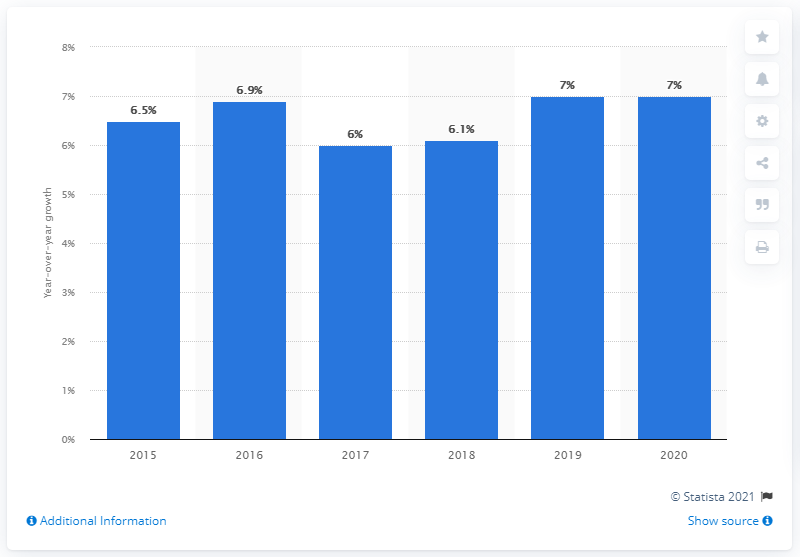Mention a couple of crucial points in this snapshot. Global business travel spending is expected to increase by 6.1% in 2018, indicating continued growth in the travel industry. 